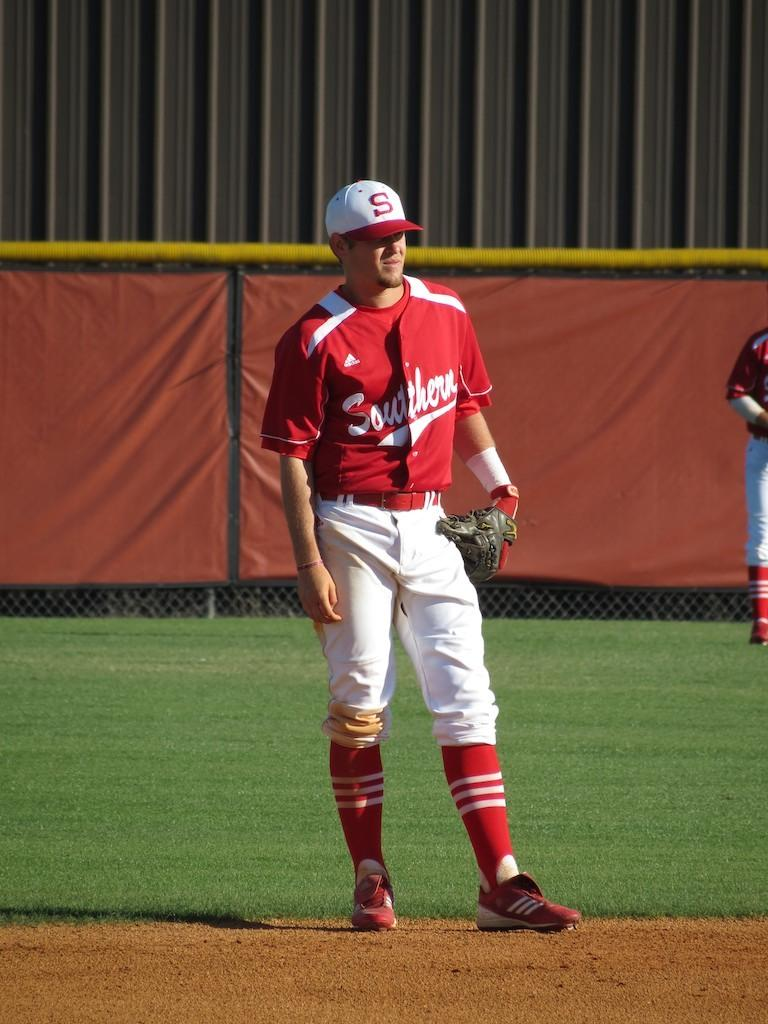<image>
Provide a brief description of the given image. A baseball player with "Southern" written on his jersey 